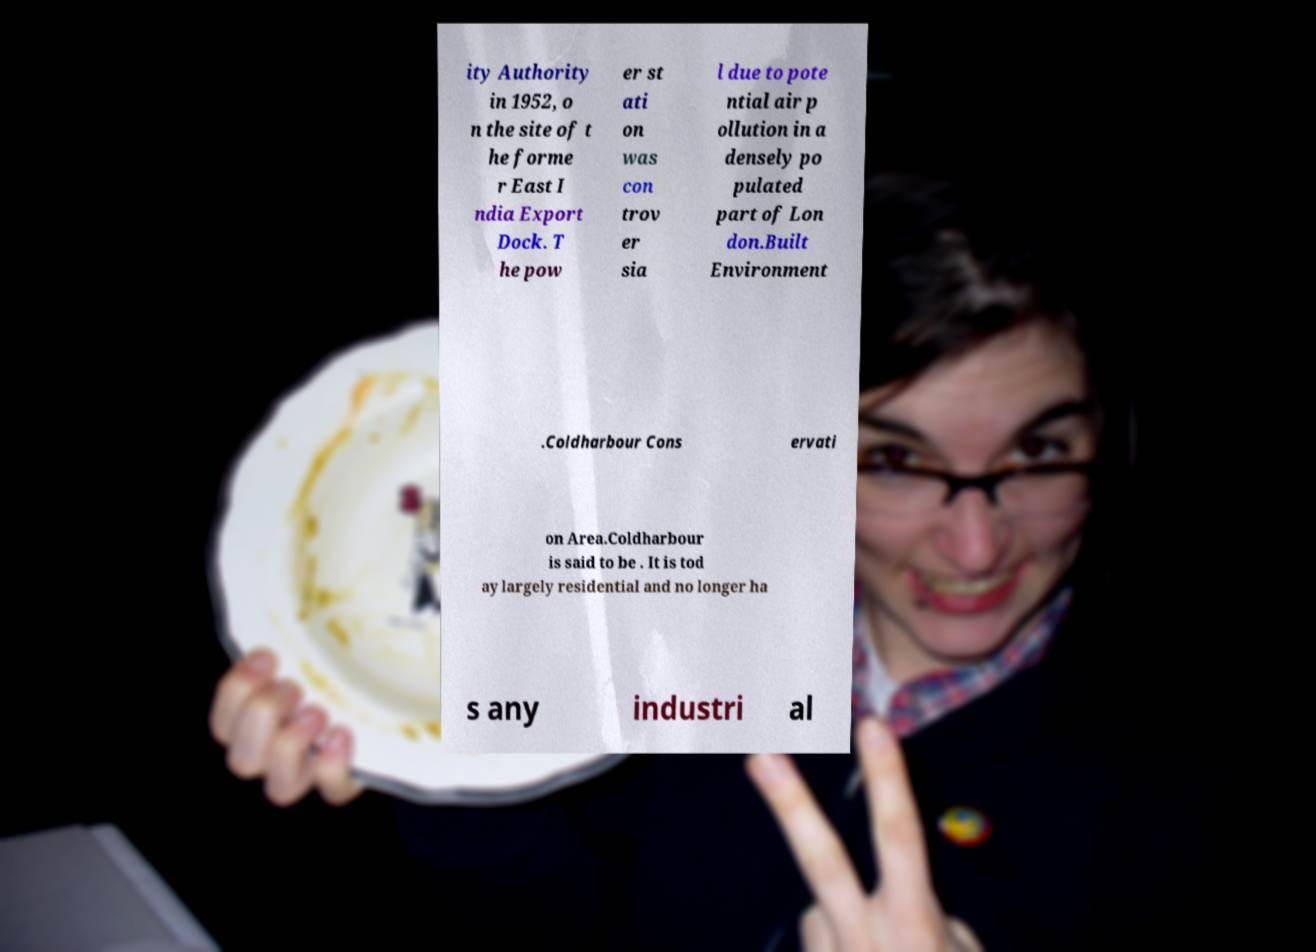Could you extract and type out the text from this image? ity Authority in 1952, o n the site of t he forme r East I ndia Export Dock. T he pow er st ati on was con trov er sia l due to pote ntial air p ollution in a densely po pulated part of Lon don.Built Environment .Coldharbour Cons ervati on Area.Coldharbour is said to be . It is tod ay largely residential and no longer ha s any industri al 